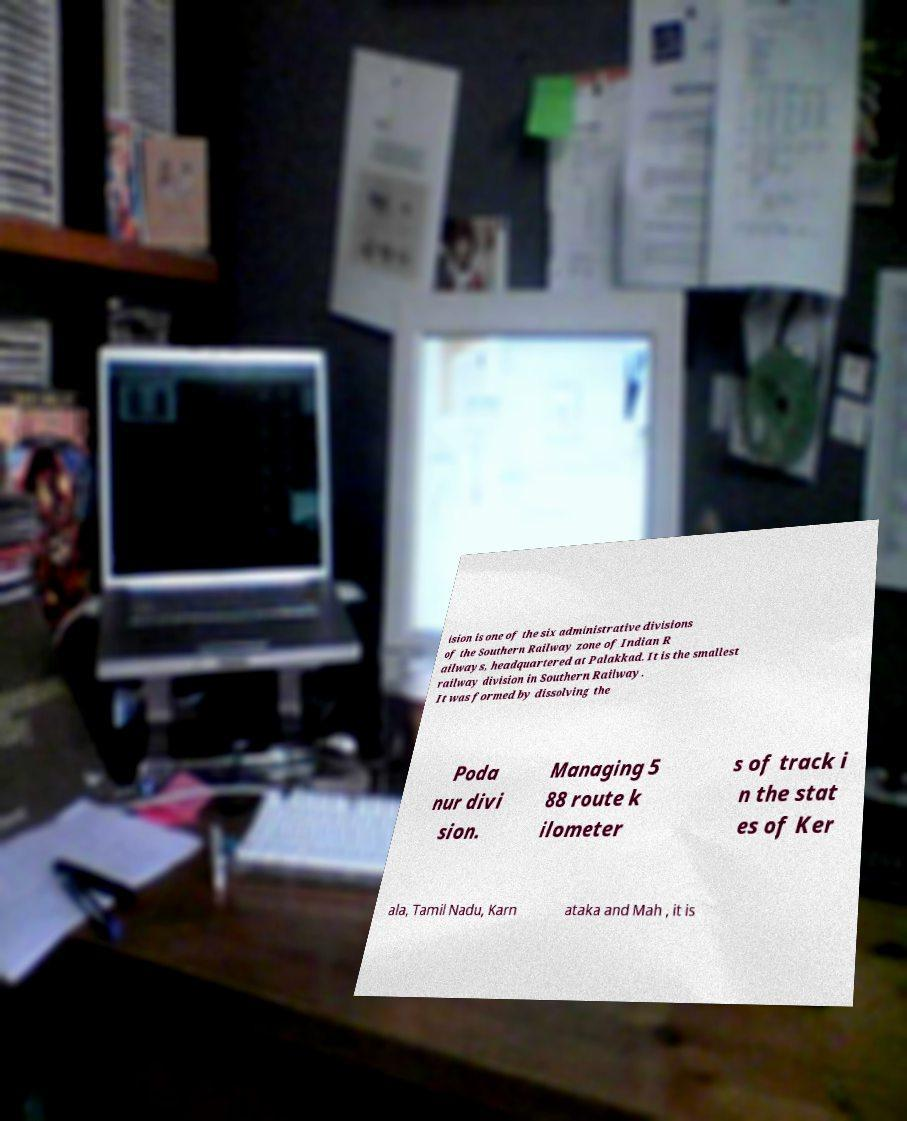Could you assist in decoding the text presented in this image and type it out clearly? ision is one of the six administrative divisions of the Southern Railway zone of Indian R ailways, headquartered at Palakkad. It is the smallest railway division in Southern Railway. It was formed by dissolving the Poda nur divi sion. Managing 5 88 route k ilometer s of track i n the stat es of Ker ala, Tamil Nadu, Karn ataka and Mah , it is 